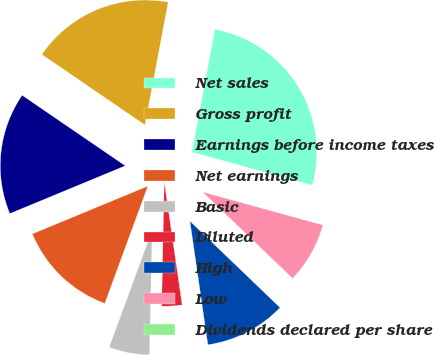Convert chart. <chart><loc_0><loc_0><loc_500><loc_500><pie_chart><fcel>Net sales<fcel>Gross profit<fcel>Earnings before income taxes<fcel>Net earnings<fcel>Basic<fcel>Diluted<fcel>High<fcel>Low<fcel>Dividends declared per share<nl><fcel>26.31%<fcel>18.42%<fcel>15.79%<fcel>13.16%<fcel>5.26%<fcel>2.63%<fcel>10.53%<fcel>7.9%<fcel>0.0%<nl></chart> 